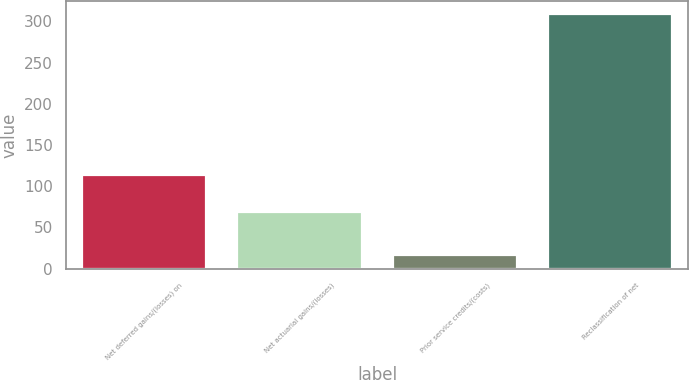Convert chart. <chart><loc_0><loc_0><loc_500><loc_500><bar_chart><fcel>Net deferred gains/(losses) on<fcel>Net actuarial gains/(losses)<fcel>Prior service credits/(costs)<fcel>Reclassification of net<nl><fcel>113<fcel>69<fcel>17<fcel>309<nl></chart> 